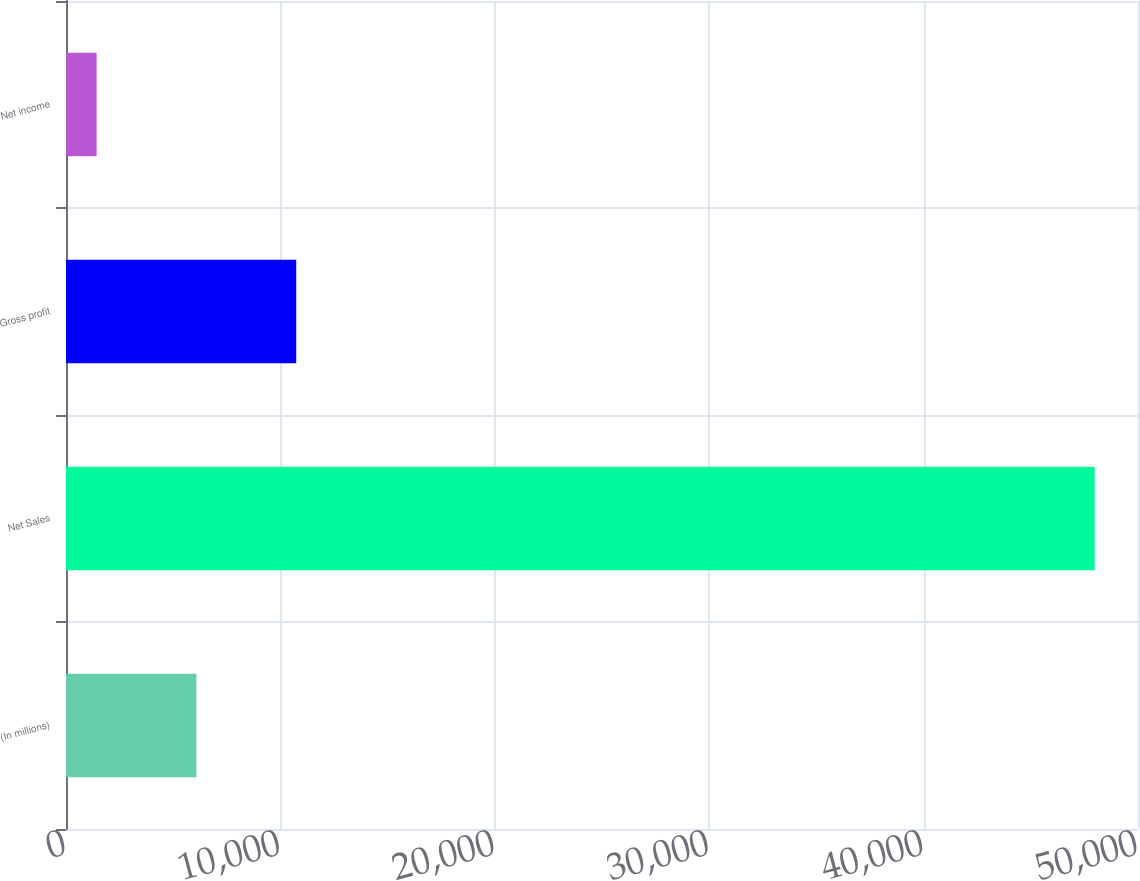Convert chart. <chart><loc_0><loc_0><loc_500><loc_500><bar_chart><fcel>(In millions)<fcel>Net Sales<fcel>Gross profit<fcel>Net income<nl><fcel>6083.2<fcel>47980<fcel>10738.4<fcel>1428<nl></chart> 